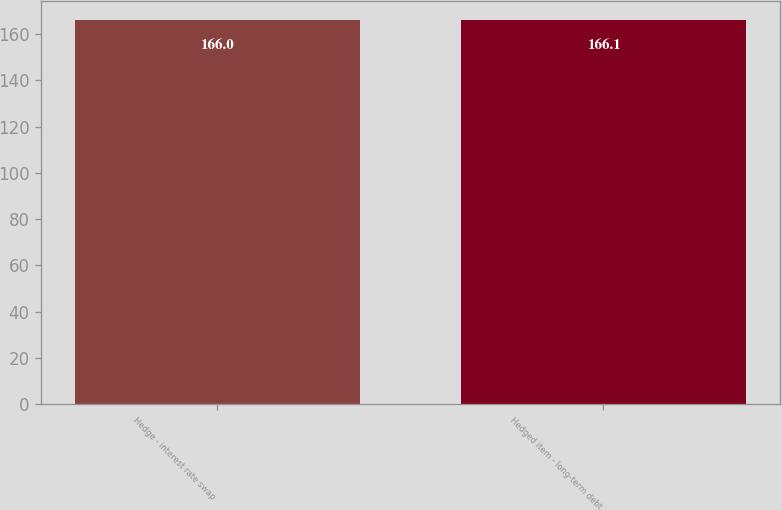<chart> <loc_0><loc_0><loc_500><loc_500><bar_chart><fcel>Hedge - interest rate swap<fcel>Hedged item - long-term debt<nl><fcel>166<fcel>166.1<nl></chart> 